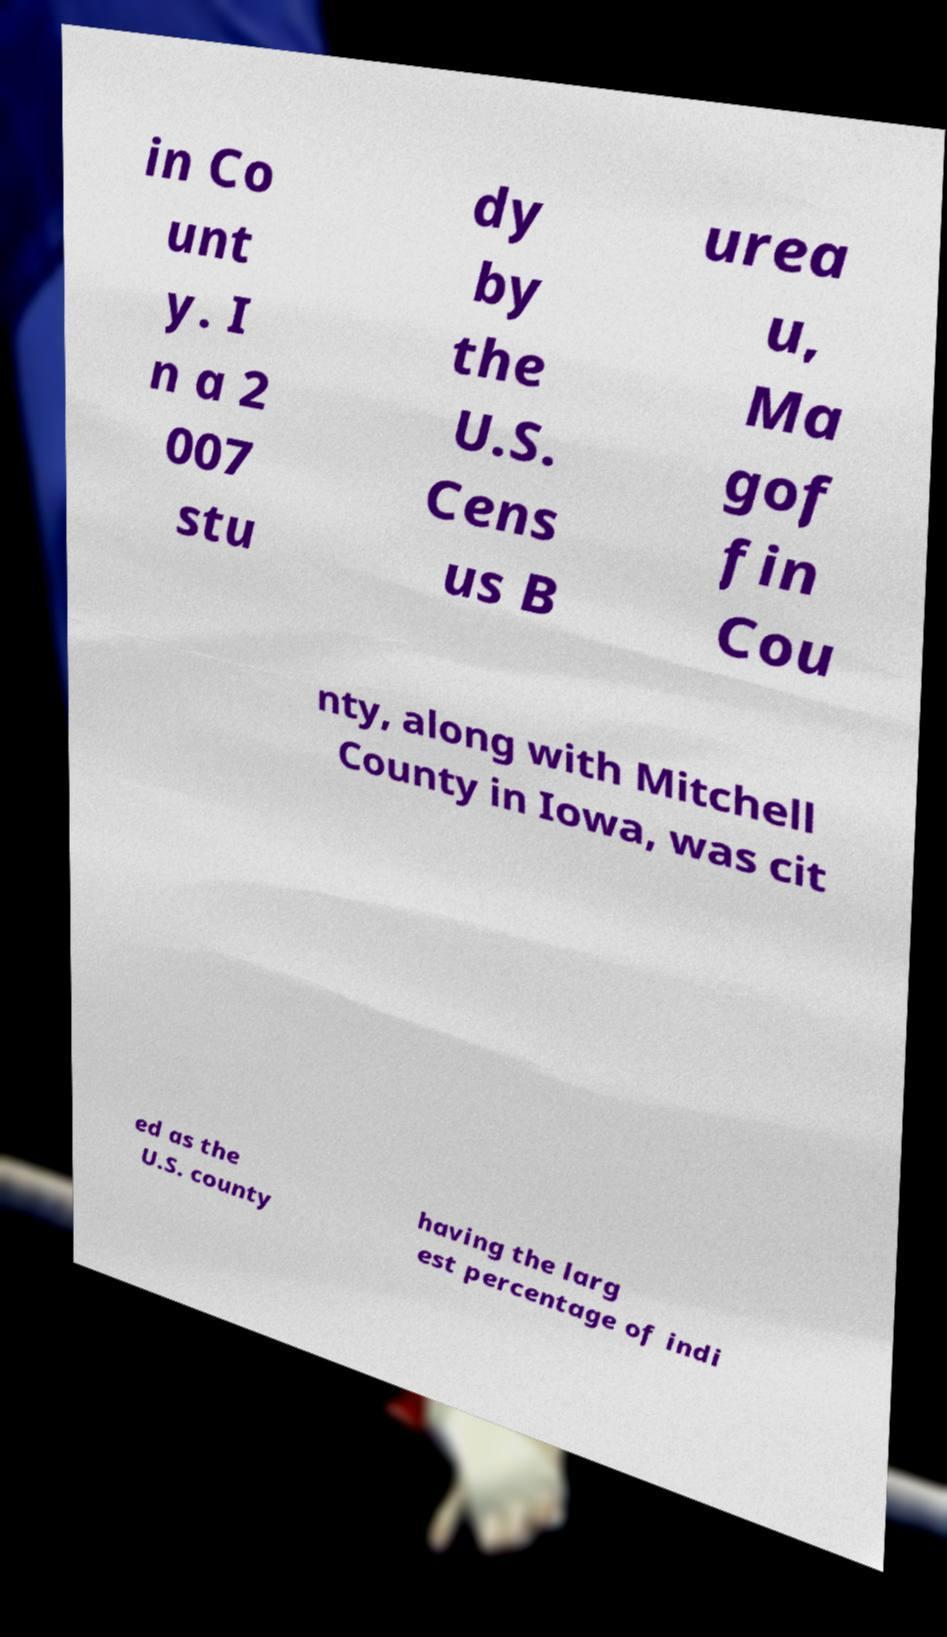Could you extract and type out the text from this image? in Co unt y. I n a 2 007 stu dy by the U.S. Cens us B urea u, Ma gof fin Cou nty, along with Mitchell County in Iowa, was cit ed as the U.S. county having the larg est percentage of indi 